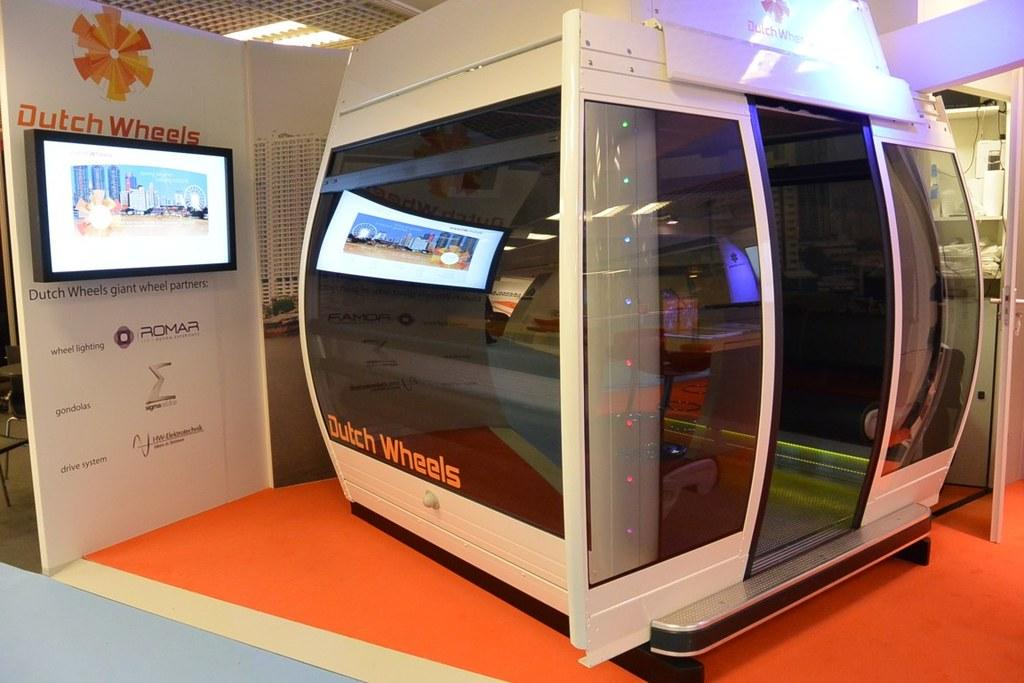<image>
Provide a brief description of the given image. A Dutch Wheels, giant wheel partners, pod is displayed on orange flooring. 